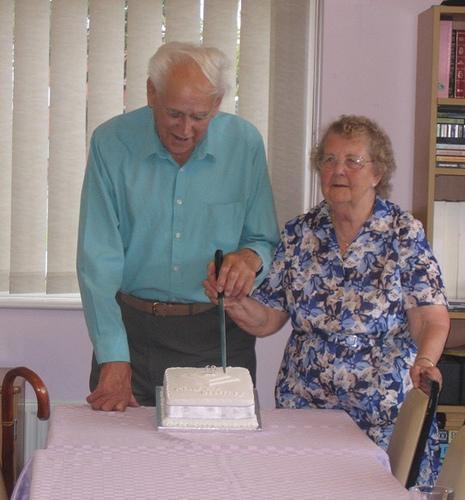How many people are in the picture?
Give a very brief answer. 2. 